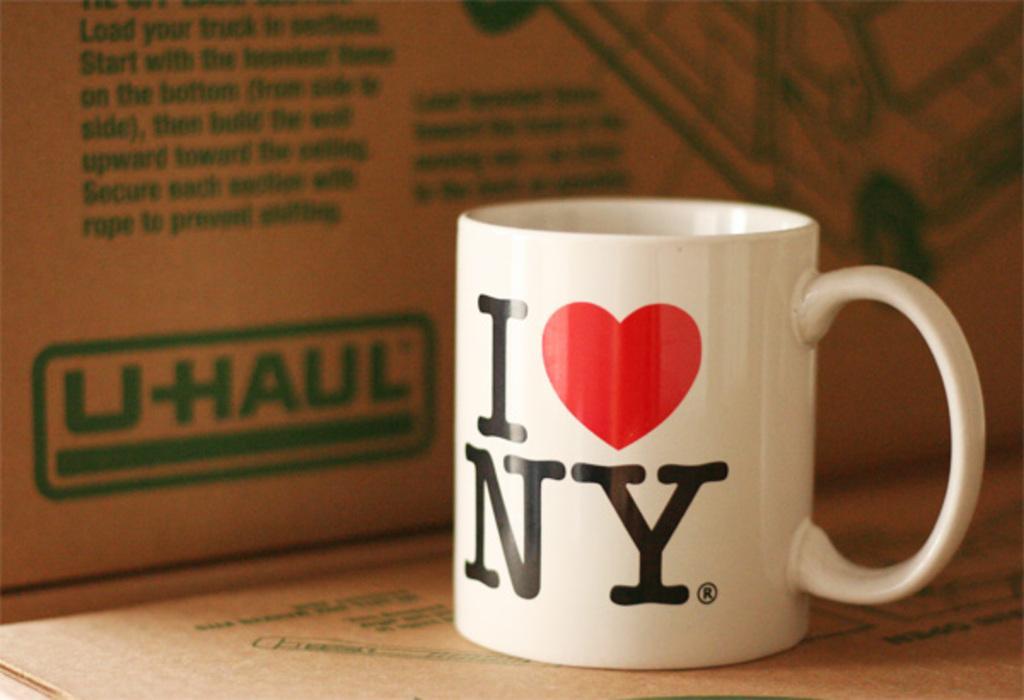Could you give a brief overview of what you see in this image? In the image there is a cup with some text and a symbol on it. Behind the cup there is a cardboard box with text and an image on it. 